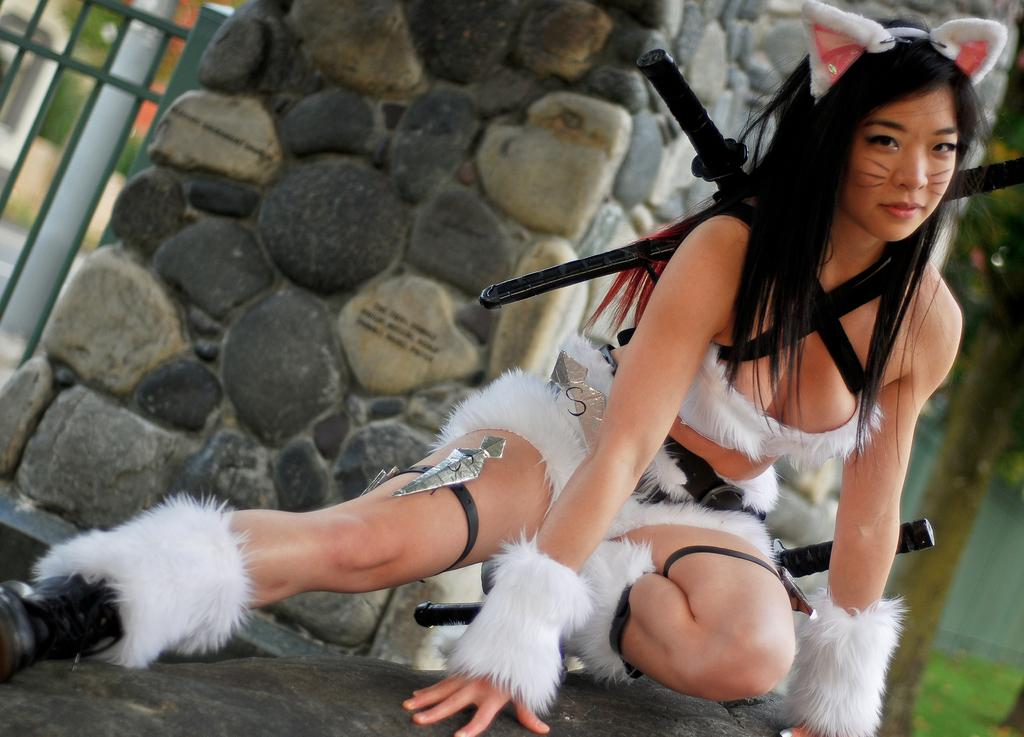Who is present in the image? There is a woman in the image. What is the woman wearing? The woman is wearing a fancy dress. What position is the woman in? The woman is in a squat position. What can be seen in the background of the image? There is a stone wall and a fence in the background of the image, as well as other unspecified things. Can you see any art or wing in the image? There is no art or wing present in the image. What type of monkey can be seen interacting with the woman in the image? There is no monkey present in the image; it only features the woman and the background elements. 